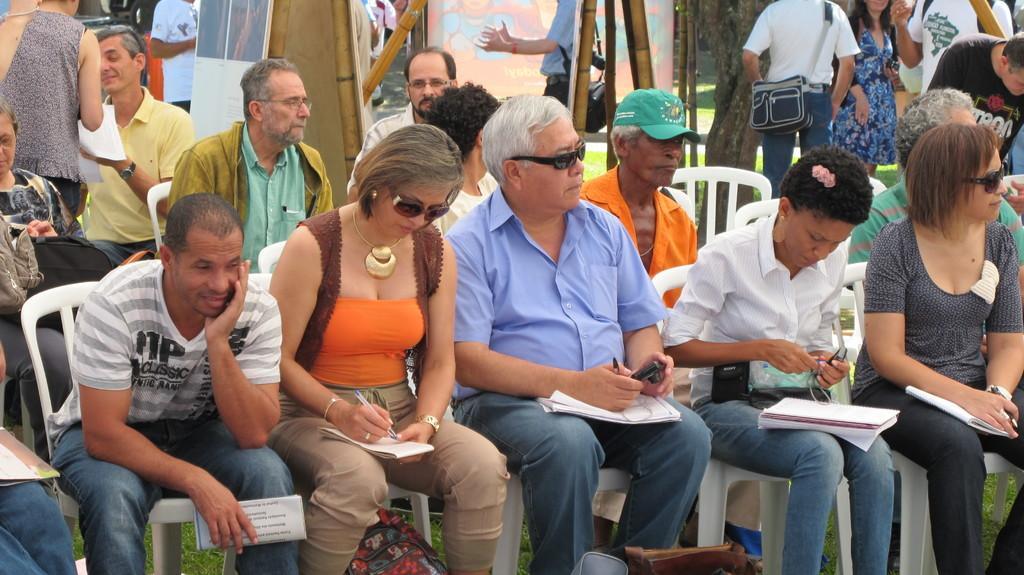How would you summarize this image in a sentence or two? In this image we can see some people sitting on chairs holding objects in their hands. In the foreground we can see some bags placed on the ground. In the background, we can see some people standing on the grass field, wooden poles and boards with some pictures. At the top of the image we can see a tree. 